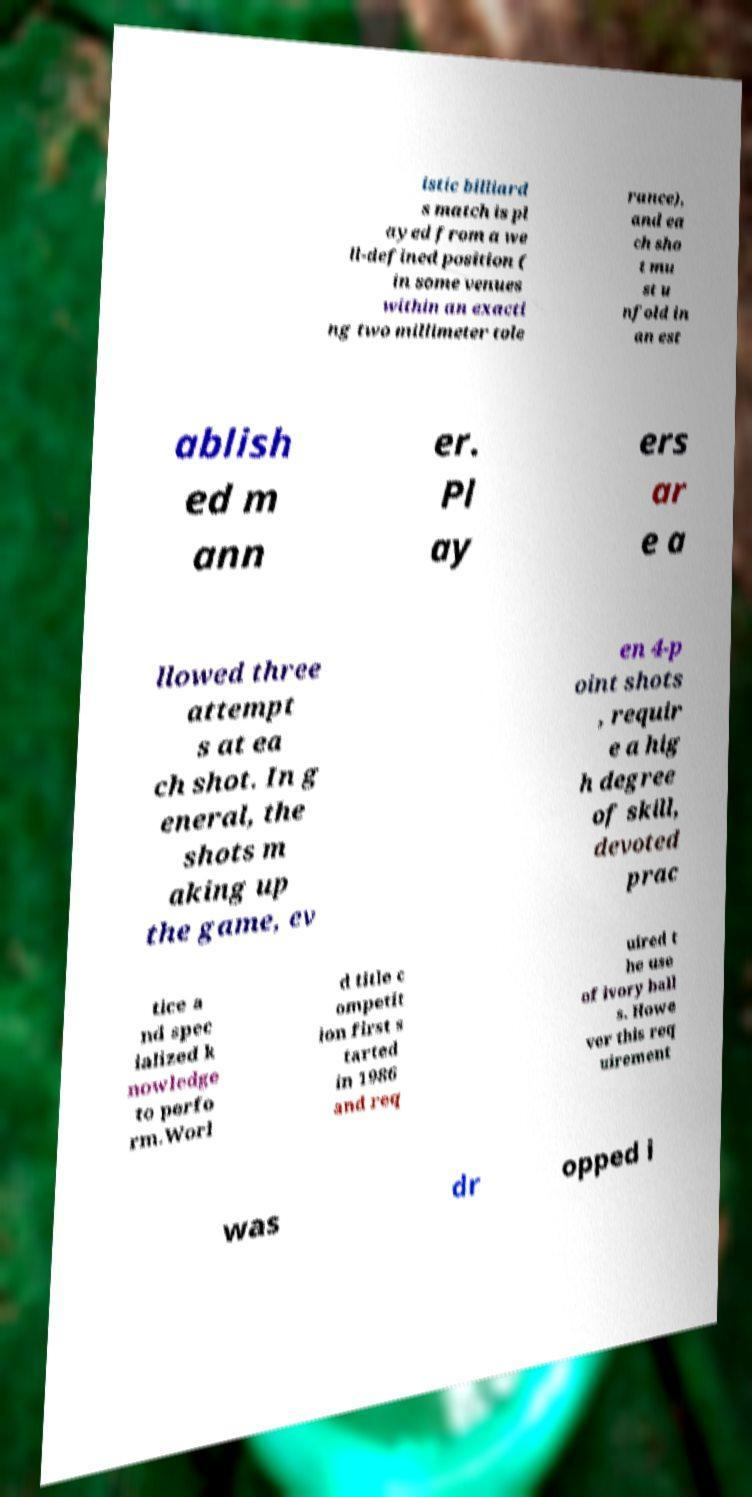Could you assist in decoding the text presented in this image and type it out clearly? istic billiard s match is pl ayed from a we ll-defined position ( in some venues within an exacti ng two millimeter tole rance), and ea ch sho t mu st u nfold in an est ablish ed m ann er. Pl ay ers ar e a llowed three attempt s at ea ch shot. In g eneral, the shots m aking up the game, ev en 4-p oint shots , requir e a hig h degree of skill, devoted prac tice a nd spec ialized k nowledge to perfo rm.Worl d title c ompetit ion first s tarted in 1986 and req uired t he use of ivory ball s. Howe ver this req uirement was dr opped i 